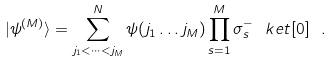Convert formula to latex. <formula><loc_0><loc_0><loc_500><loc_500>| \psi ^ { ( M ) } \rangle = \sum _ { j _ { 1 } < \dots < j _ { M } } ^ { N } \psi ( j _ { 1 } \dots j _ { M } ) \prod _ { s = 1 } ^ { M } \sigma _ { s } ^ { - } \ k e t [ 0 ] \ .</formula> 